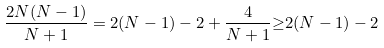<formula> <loc_0><loc_0><loc_500><loc_500>\frac { 2 N ( N - 1 ) } { N + 1 } = 2 ( N - 1 ) - 2 + \frac { 4 } { N + 1 } { \geq } 2 ( N - 1 ) - 2</formula> 